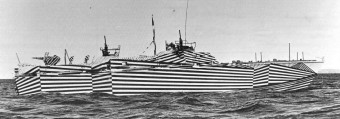Could ships painted like this still be effective today? Dazzle camouflage is less relevant in modern naval warfare due to advances in radar and satellite technology. Today's targeting systems rely less on visual perception and more on electronic and digital information, making such patterns obsolete for concealing ships. 